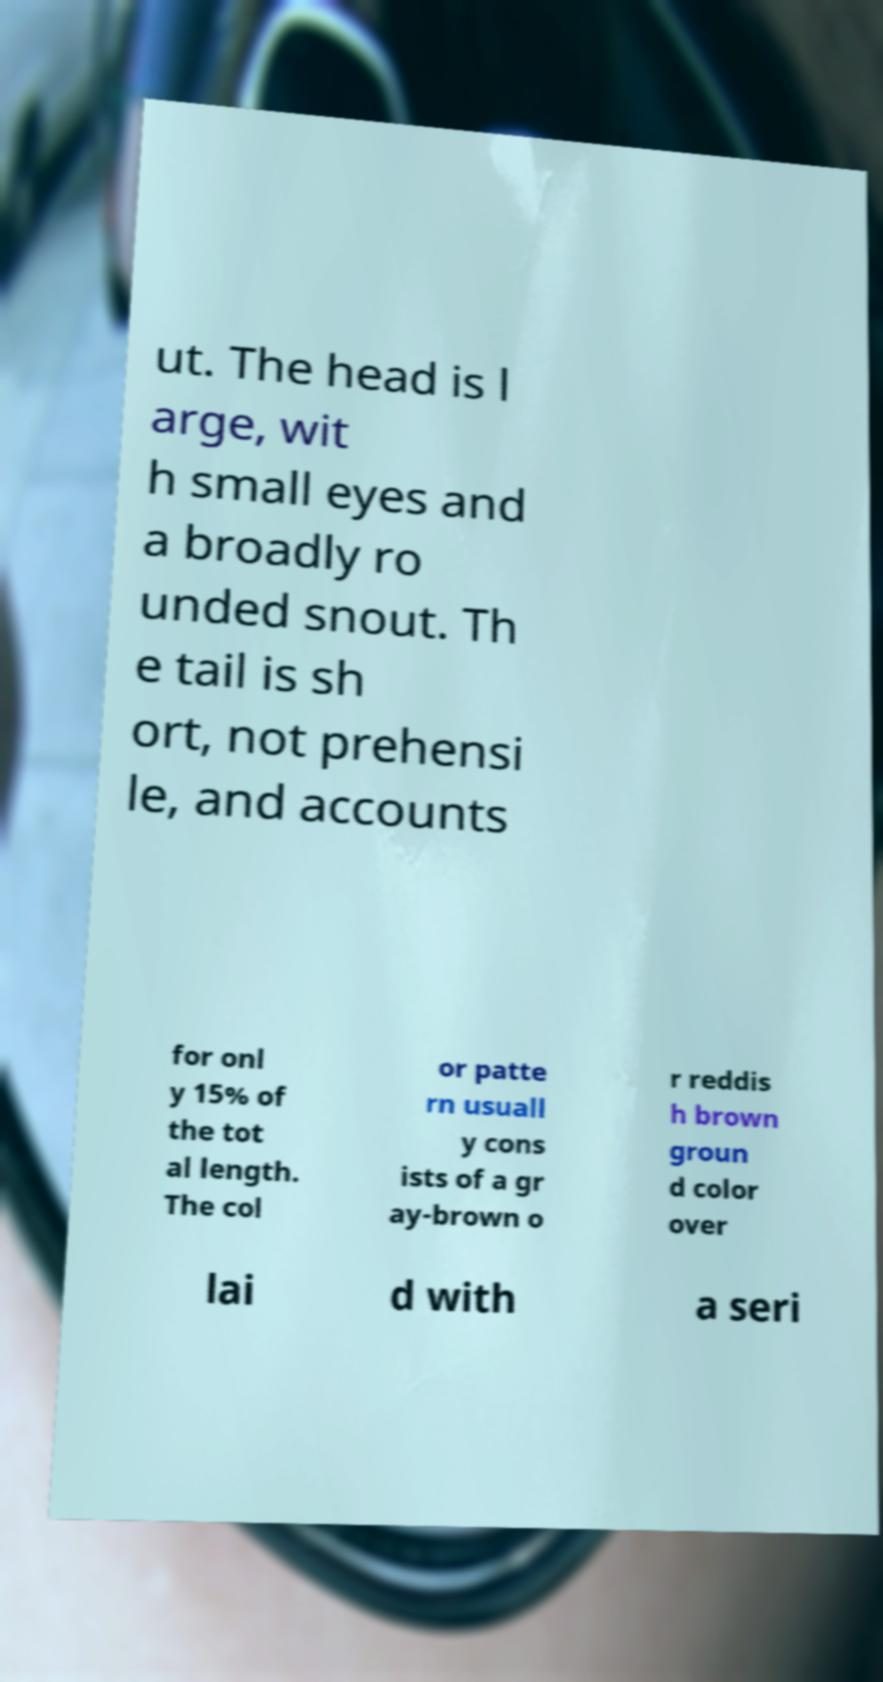Can you accurately transcribe the text from the provided image for me? ut. The head is l arge, wit h small eyes and a broadly ro unded snout. Th e tail is sh ort, not prehensi le, and accounts for onl y 15% of the tot al length. The col or patte rn usuall y cons ists of a gr ay-brown o r reddis h brown groun d color over lai d with a seri 